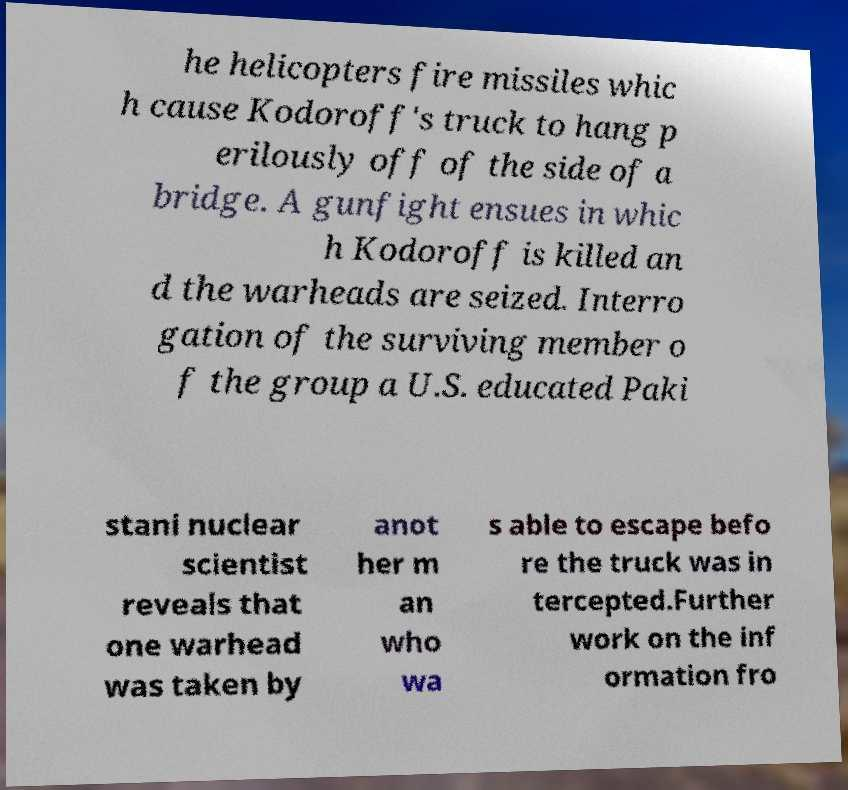Can you accurately transcribe the text from the provided image for me? he helicopters fire missiles whic h cause Kodoroff's truck to hang p erilously off of the side of a bridge. A gunfight ensues in whic h Kodoroff is killed an d the warheads are seized. Interro gation of the surviving member o f the group a U.S. educated Paki stani nuclear scientist reveals that one warhead was taken by anot her m an who wa s able to escape befo re the truck was in tercepted.Further work on the inf ormation fro 